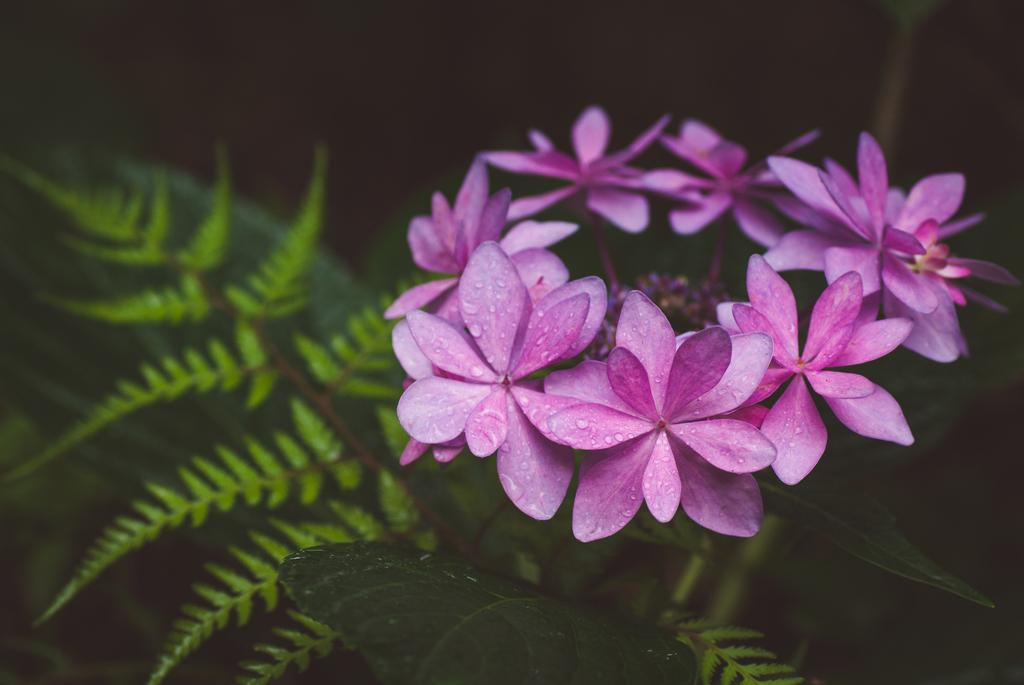What type of plants are visible in the image? There are flowers in the image. What color are the flowers? The flowers are pink in color. Are there any other parts of the plants visible in the image? Yes, there are leaves in the image. Can you see any sea creatures swimming near the flowers in the image? There is no sea or sea creatures present in the image; it features flowers and leaves. 